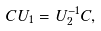<formula> <loc_0><loc_0><loc_500><loc_500>C U _ { 1 } = U _ { 2 } ^ { - 1 } C ,</formula> 